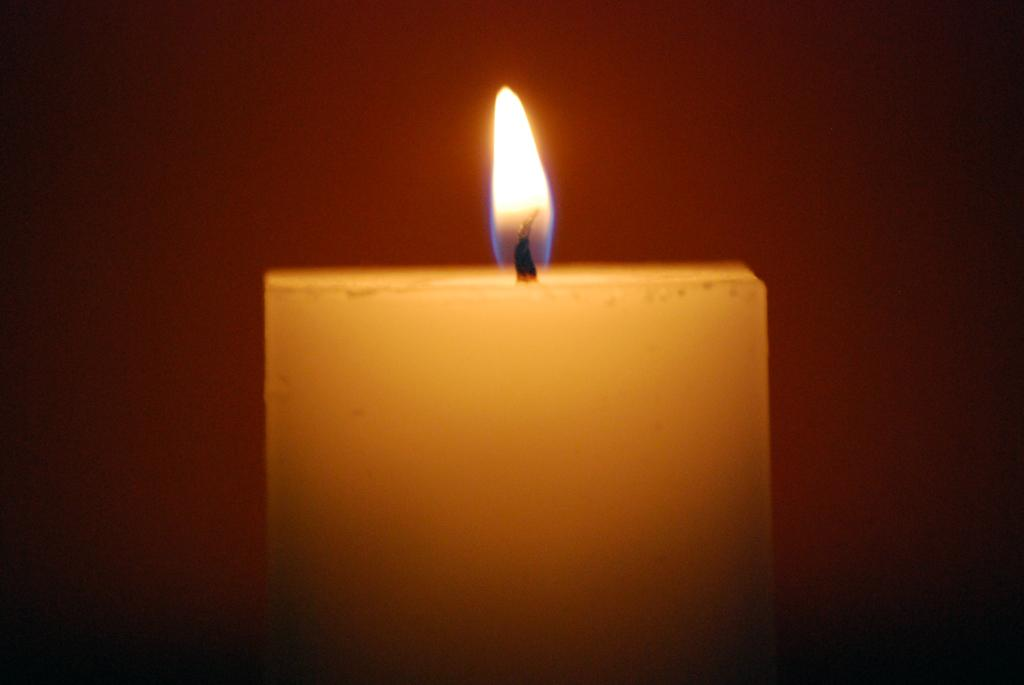What is the main object in the center of the image? There is a candle in the center of the image. What can be seen in the background of the image? There is a wall in the background of the image. How many clams are present on the candle in the image? There are no clams present on the candle in the image. What unit of measurement is used to determine the height of the flame on the candle? The image does not provide information about the height of the flame or any unit of measurement. 